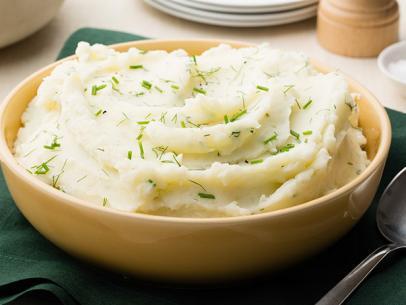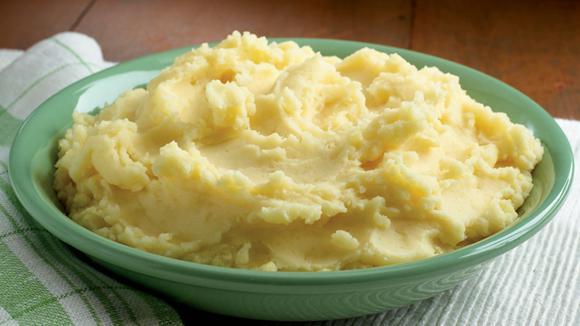The first image is the image on the left, the second image is the image on the right. Analyze the images presented: Is the assertion "In one image, mashed potatoes are served on a plate with a vegetable and a meat or fish course, while a second image shows mashed potatoes with flecks of chive." valid? Answer yes or no. No. The first image is the image on the left, the second image is the image on the right. Considering the images on both sides, is "There are cut vegetables next to a mashed potato on a plate  in the left image." valid? Answer yes or no. No. 